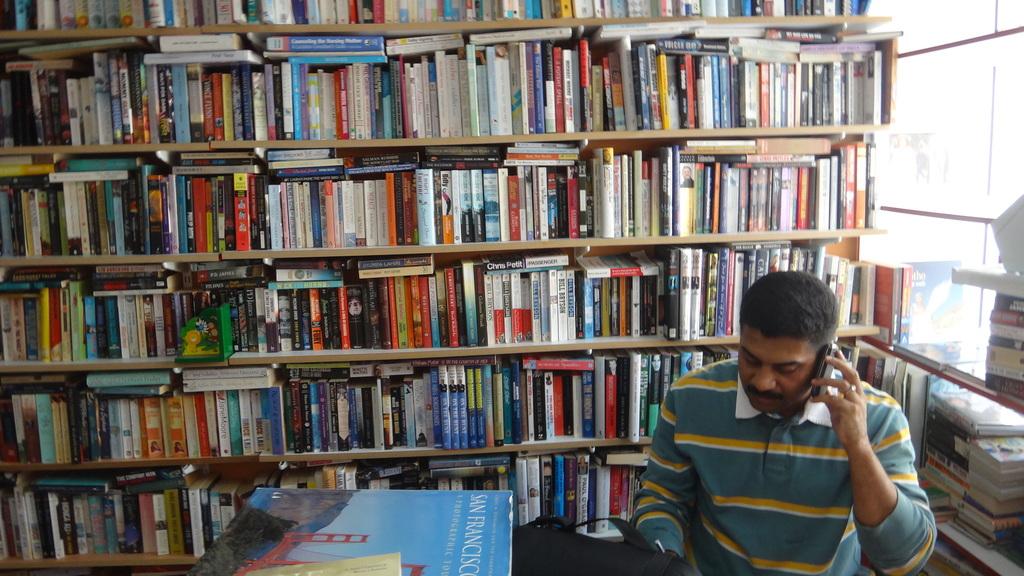What city is on the book on his desk?
Give a very brief answer. San francisco. What is the name of one of the books on the shelf?
Provide a succinct answer. San francisco. 